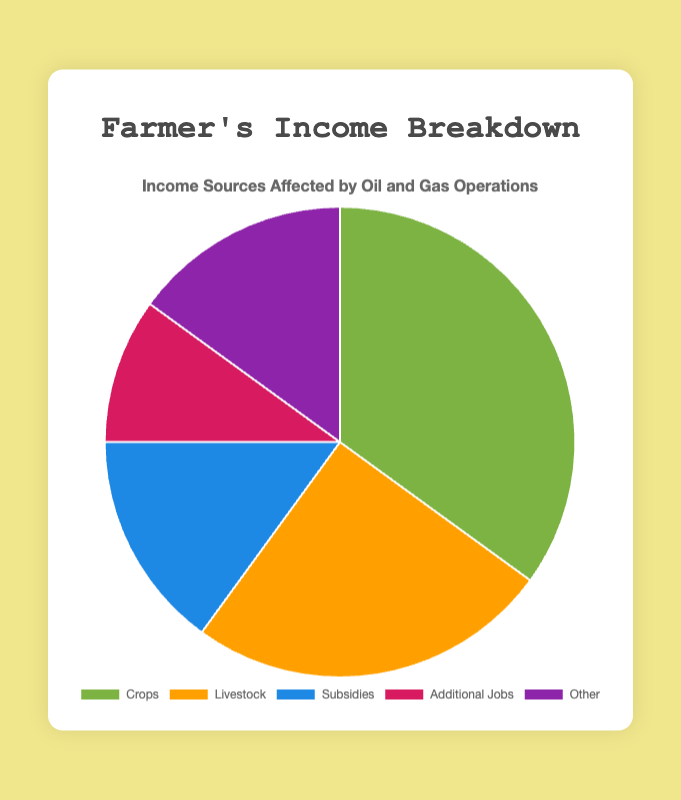What percentage of the total income does 'Livestock' contribute? 'Livestock' contributes 25% of the total income according to the pie chart. Look at the section labeled 'Livestock' and check the corresponding percentage value.
Answer: 25% Which income source contributes the least to total income? From the pie chart, the income source that contributes the least is 'Additional Jobs' as it occupies the smallest section and has a value of 10%.
Answer: Additional Jobs What is the combined percentage of 'Subsidies' and 'Other'? To find the combined percentage, add the individual percentages of 'Subsidies' and 'Other'. According to the chart, 'Subsidies' is 15% and 'Other' is also 15%. So, 15% + 15% = 30%.
Answer: 30% Which income source has a higher contribution: 'Crops' or 'Livestock'? Compare the percentages of 'Crops' and 'Livestock' on the pie chart. 'Crops' contributes 35% while 'Livestock' contributes 25%. Therefore, 'Crops' has a higher contribution.
Answer: Crops If 'Crops,' 'Livestock,' and 'Subsidies' represent essential farming activities, what percentage do these activities contribute to the total income? Add the percentages of 'Crops,' 'Livestock,' and 'Subsidies.' According to the chart, 'Crops' is 35%, 'Livestock' is 25%, and 'Subsidies' is 15%. So, 35% + 25% + 15% = 75%.
Answer: 75% How much more does 'Crops' contribute compared to 'Additional Jobs'? Subtract the percentage of 'Additional Jobs' from the percentage of 'Crops.' According to the chart, 'Crops' is 35% and 'Additional Jobs' is 10%. So, 35% - 10% = 25%.
Answer: 25% Rank the income sources from highest to lowest based on their contributions. List the income sources in descending order of their percentages: 'Crops' (35%), 'Livestock' (25%), 'Subsidies' (15%), 'Other' (15%), 'Additional Jobs' (10%). The color or section size on the pie chart helps in visual comparison.
Answer: Crops, Livestock, Subsidies, Other, Additional Jobs 